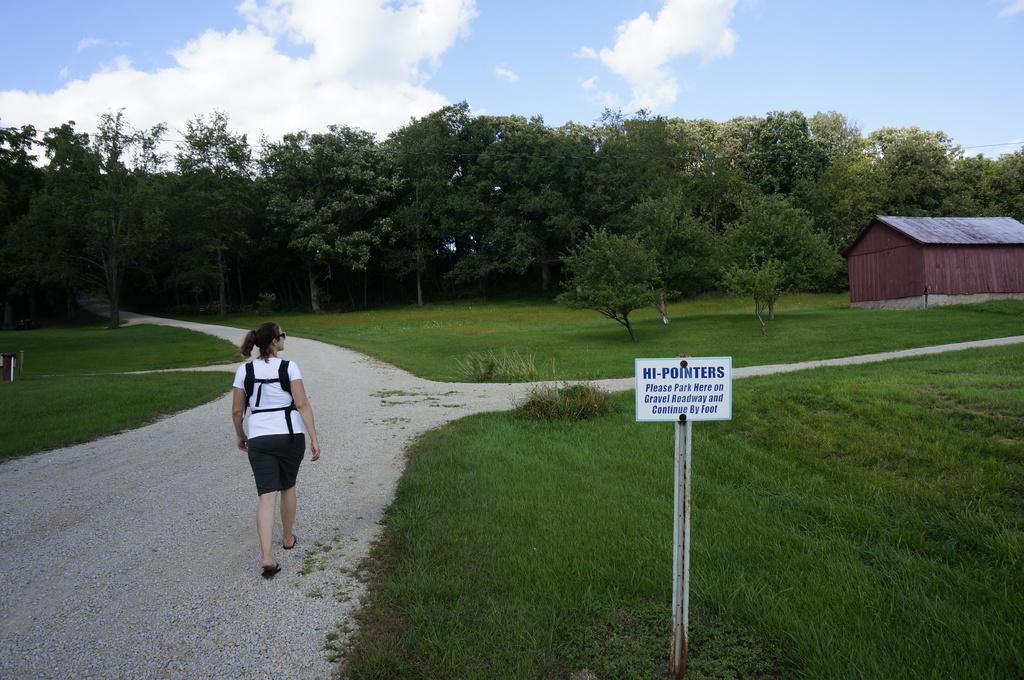How would you summarize this image in a sentence or two? On the left side a woman is walking on the way, she wore white color t-shirt and a black color short. On the right side there is a board and a wooden house, in the middle there are trees in this image. At the top it is the cloudy sky. 